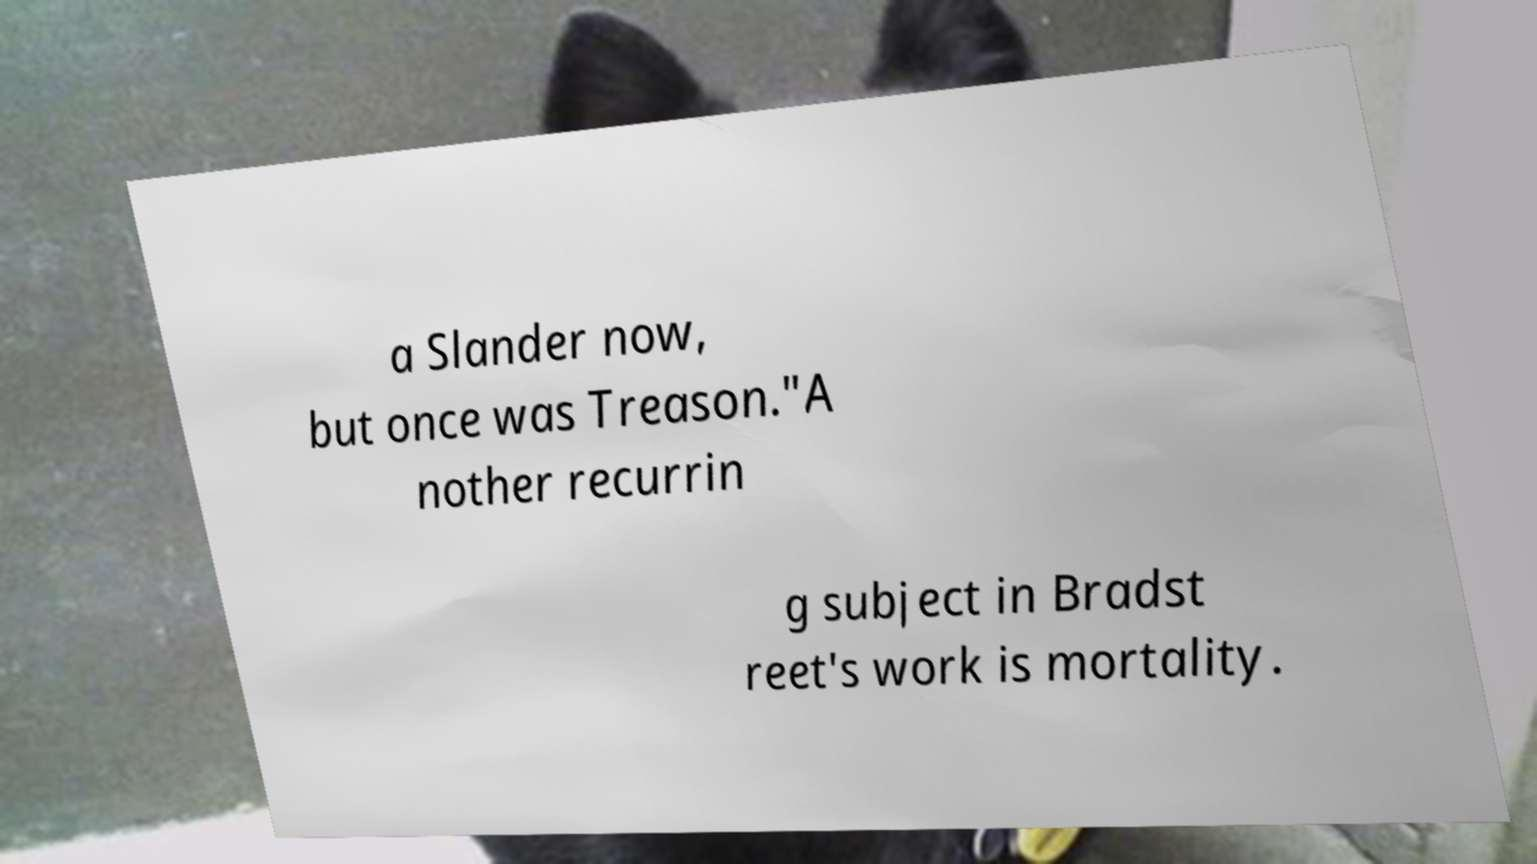For documentation purposes, I need the text within this image transcribed. Could you provide that? a Slander now, but once was Treason."A nother recurrin g subject in Bradst reet's work is mortality. 